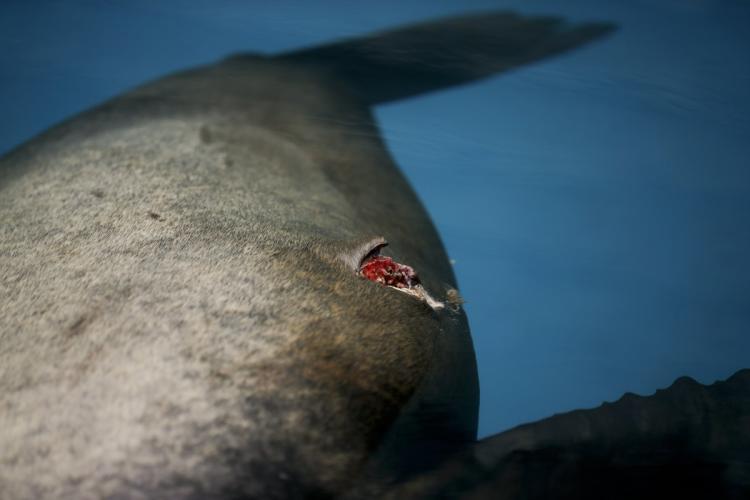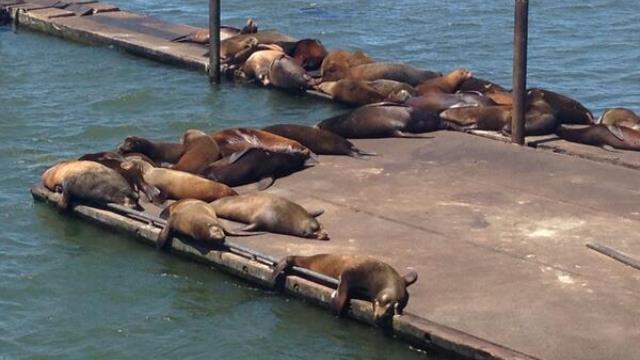The first image is the image on the left, the second image is the image on the right. Examine the images to the left and right. Is the description "An image shows seals lying on a pier that has a narrow section extending out." accurate? Answer yes or no. Yes. 